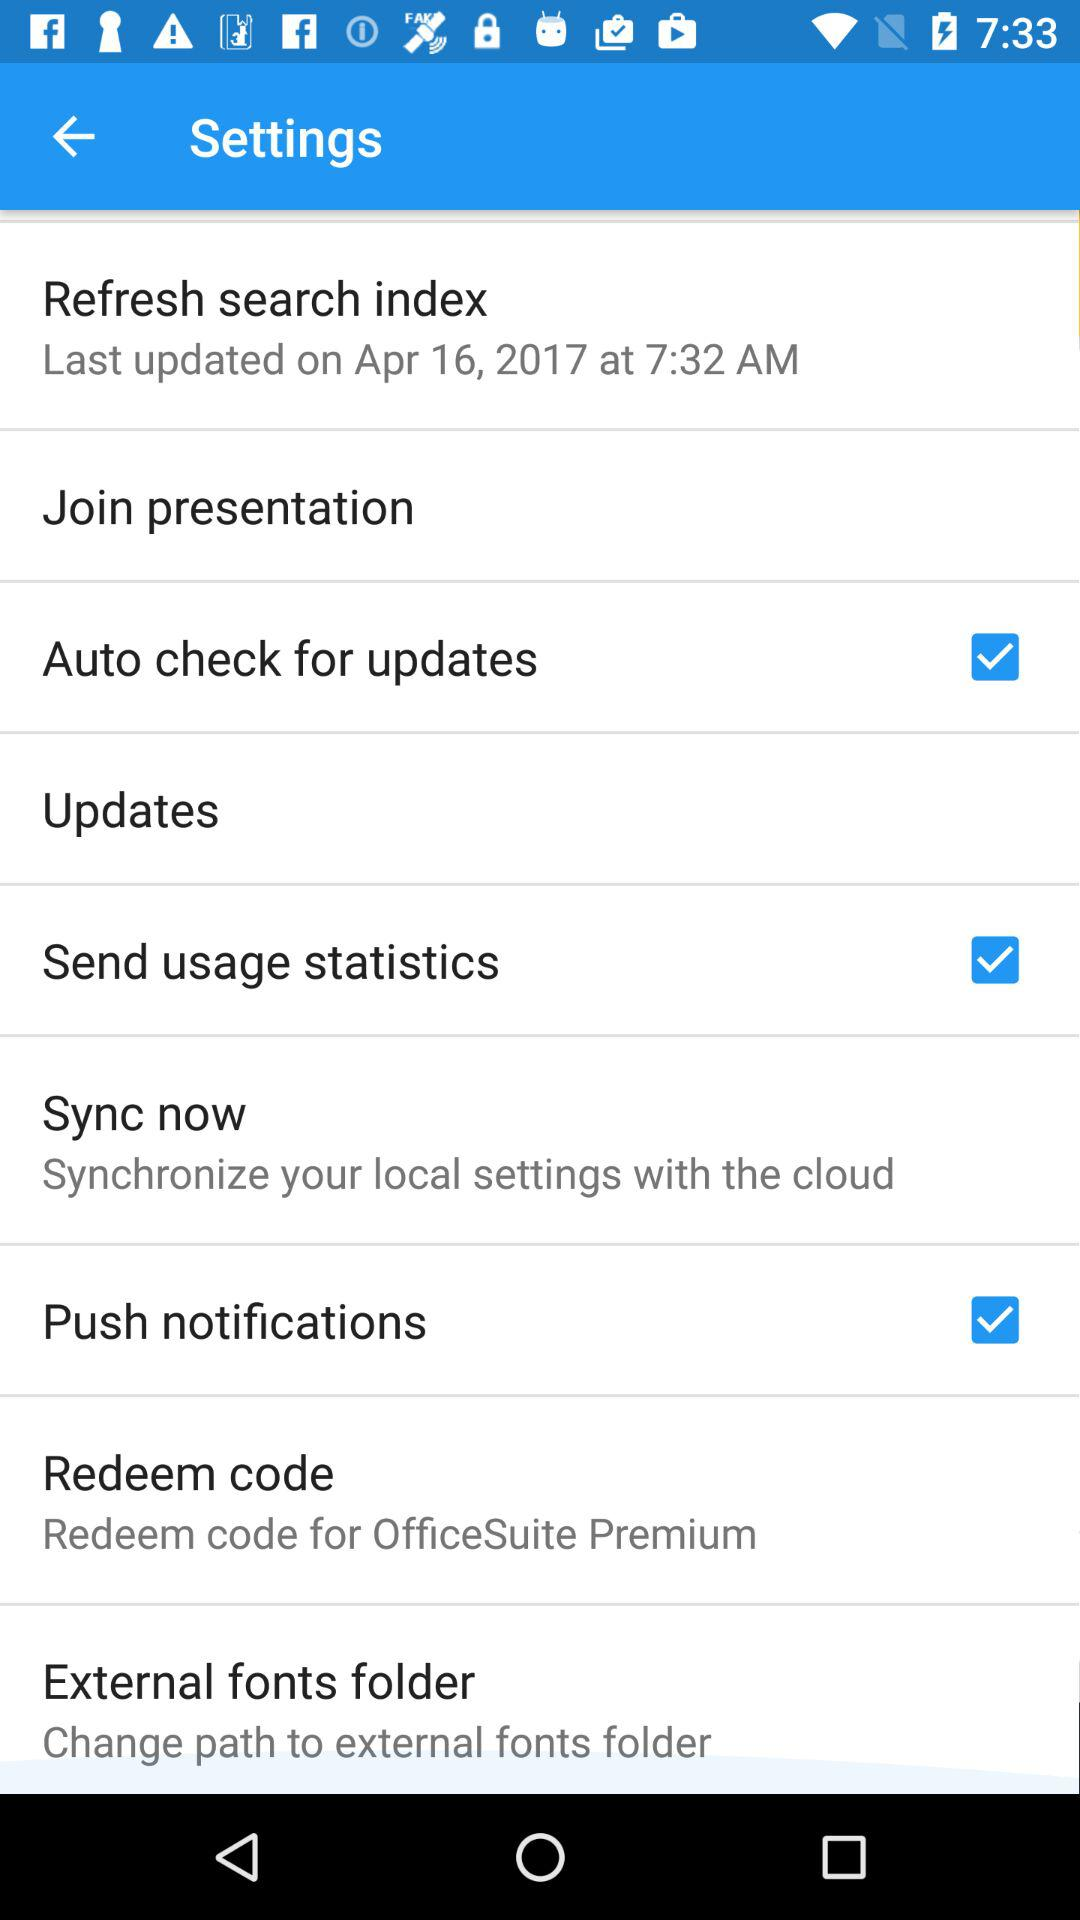What is the status of "Push notifications"? The status of "Push notifications" is "on". 